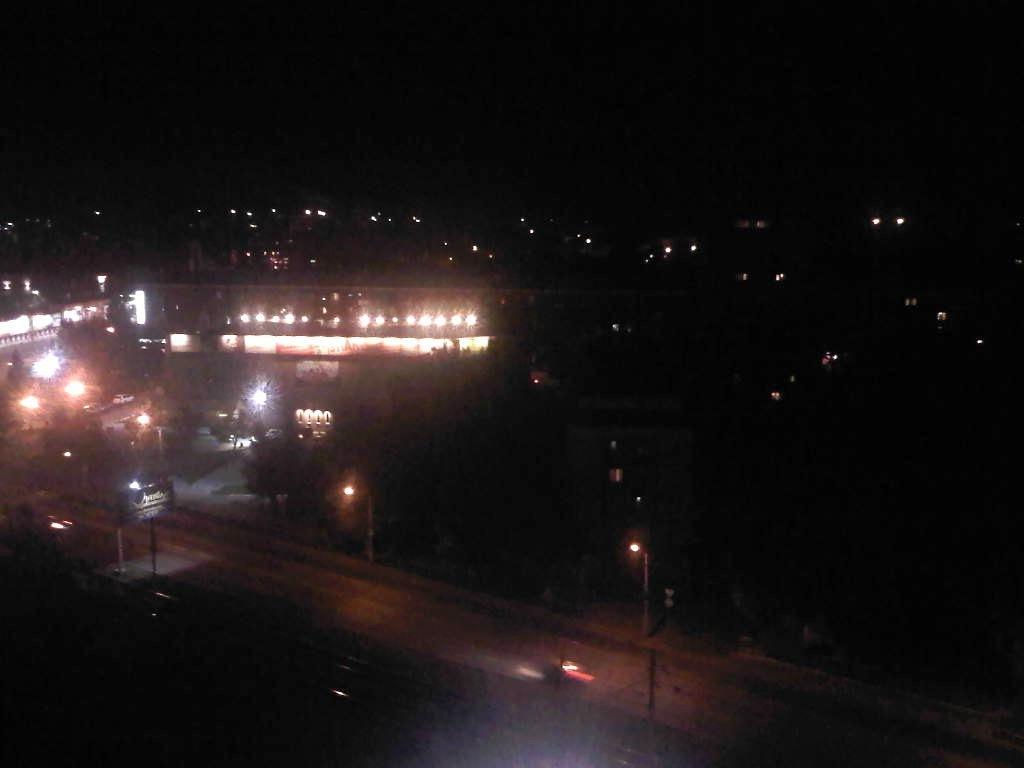In one or two sentences, can you explain what this image depicts? This image consists of crowd, light poles, vehicles, boards, buildings and the sky. This image is taken may be during night. 